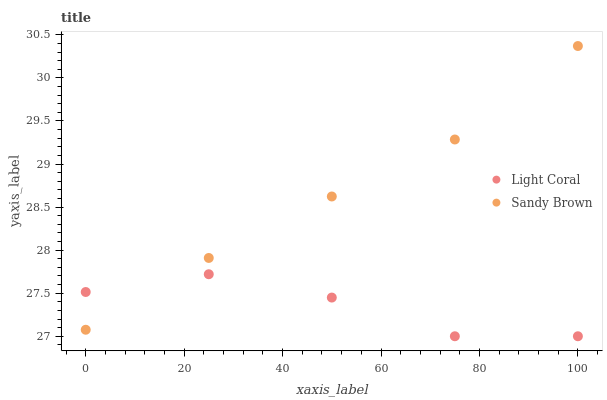Does Light Coral have the minimum area under the curve?
Answer yes or no. Yes. Does Sandy Brown have the maximum area under the curve?
Answer yes or no. Yes. Does Sandy Brown have the minimum area under the curve?
Answer yes or no. No. Is Sandy Brown the smoothest?
Answer yes or no. Yes. Is Light Coral the roughest?
Answer yes or no. Yes. Is Sandy Brown the roughest?
Answer yes or no. No. Does Light Coral have the lowest value?
Answer yes or no. Yes. Does Sandy Brown have the lowest value?
Answer yes or no. No. Does Sandy Brown have the highest value?
Answer yes or no. Yes. Does Sandy Brown intersect Light Coral?
Answer yes or no. Yes. Is Sandy Brown less than Light Coral?
Answer yes or no. No. Is Sandy Brown greater than Light Coral?
Answer yes or no. No. 